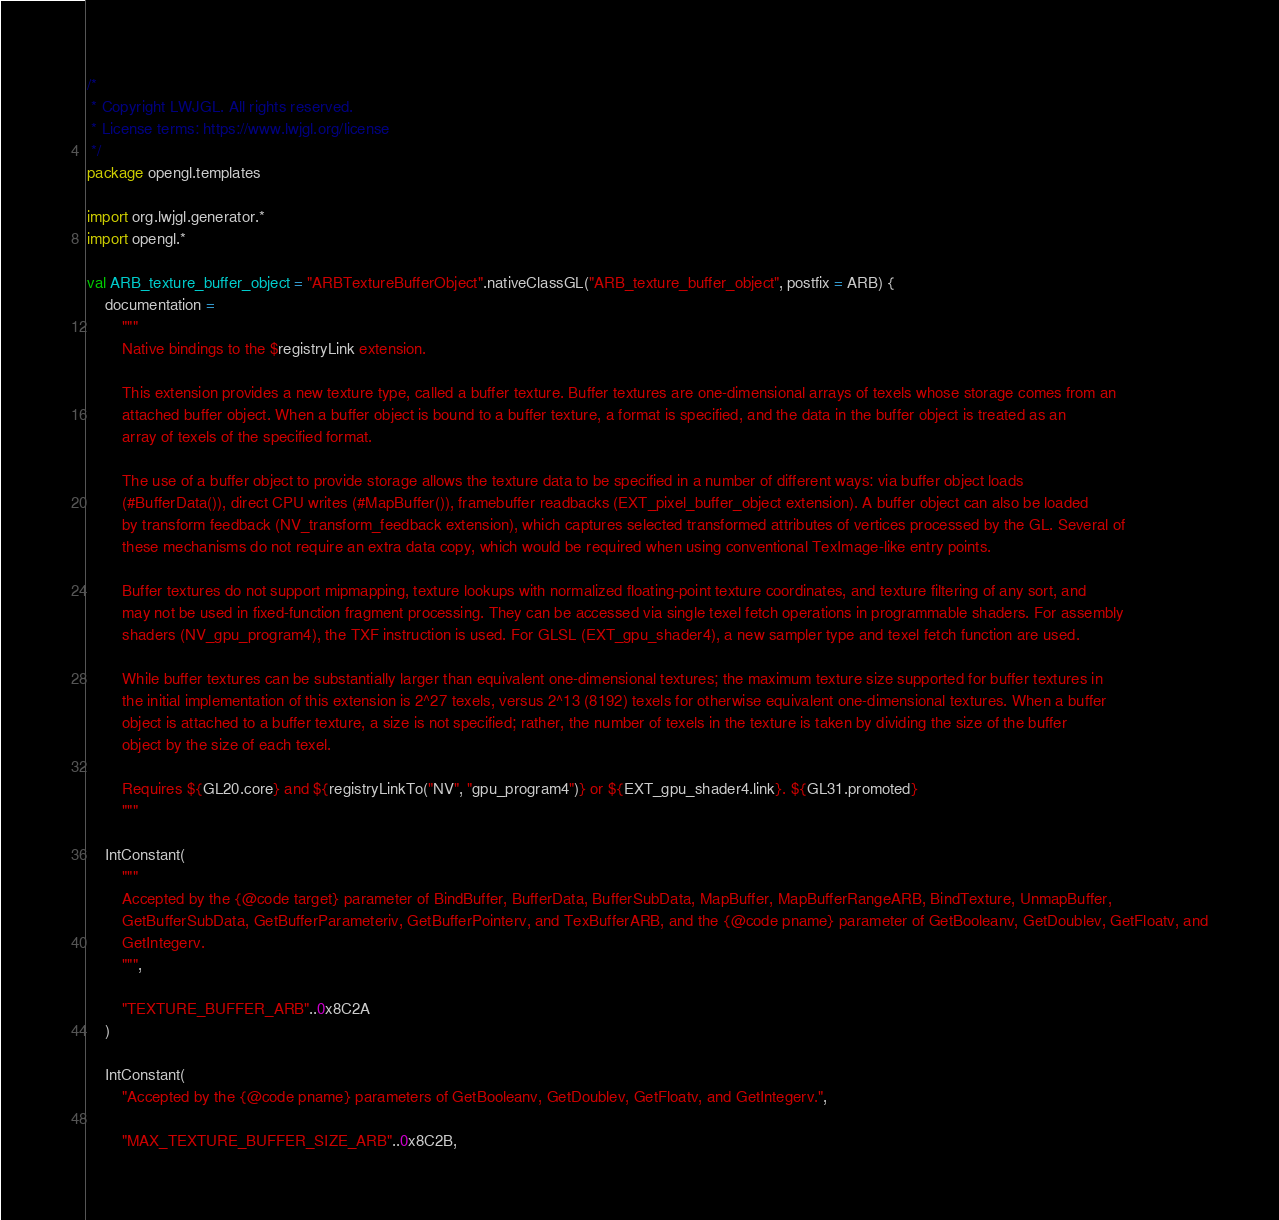<code> <loc_0><loc_0><loc_500><loc_500><_Kotlin_>/*
 * Copyright LWJGL. All rights reserved.
 * License terms: https://www.lwjgl.org/license
 */
package opengl.templates

import org.lwjgl.generator.*
import opengl.*

val ARB_texture_buffer_object = "ARBTextureBufferObject".nativeClassGL("ARB_texture_buffer_object", postfix = ARB) {
    documentation =
        """
        Native bindings to the $registryLink extension.

        This extension provides a new texture type, called a buffer texture. Buffer textures are one-dimensional arrays of texels whose storage comes from an
        attached buffer object. When a buffer object is bound to a buffer texture, a format is specified, and the data in the buffer object is treated as an
        array of texels of the specified format.

        The use of a buffer object to provide storage allows the texture data to be specified in a number of different ways: via buffer object loads
        (#BufferData()), direct CPU writes (#MapBuffer()), framebuffer readbacks (EXT_pixel_buffer_object extension). A buffer object can also be loaded
        by transform feedback (NV_transform_feedback extension), which captures selected transformed attributes of vertices processed by the GL. Several of
        these mechanisms do not require an extra data copy, which would be required when using conventional TexImage-like entry points.

        Buffer textures do not support mipmapping, texture lookups with normalized floating-point texture coordinates, and texture filtering of any sort, and
        may not be used in fixed-function fragment processing. They can be accessed via single texel fetch operations in programmable shaders. For assembly
        shaders (NV_gpu_program4), the TXF instruction is used. For GLSL (EXT_gpu_shader4), a new sampler type and texel fetch function are used.

        While buffer textures can be substantially larger than equivalent one-dimensional textures; the maximum texture size supported for buffer textures in
        the initial implementation of this extension is 2^27 texels, versus 2^13 (8192) texels for otherwise equivalent one-dimensional textures. When a buffer
        object is attached to a buffer texture, a size is not specified; rather, the number of texels in the texture is taken by dividing the size of the buffer
        object by the size of each texel.

        Requires ${GL20.core} and ${registryLinkTo("NV", "gpu_program4")} or ${EXT_gpu_shader4.link}. ${GL31.promoted}
        """

    IntConstant(
        """
        Accepted by the {@code target} parameter of BindBuffer, BufferData, BufferSubData, MapBuffer, MapBufferRangeARB, BindTexture, UnmapBuffer,
        GetBufferSubData, GetBufferParameteriv, GetBufferPointerv, and TexBufferARB, and the {@code pname} parameter of GetBooleanv, GetDoublev, GetFloatv, and
        GetIntegerv.
        """,

        "TEXTURE_BUFFER_ARB"..0x8C2A
    )

    IntConstant(
        "Accepted by the {@code pname} parameters of GetBooleanv, GetDoublev, GetFloatv, and GetIntegerv.",

        "MAX_TEXTURE_BUFFER_SIZE_ARB"..0x8C2B,</code> 